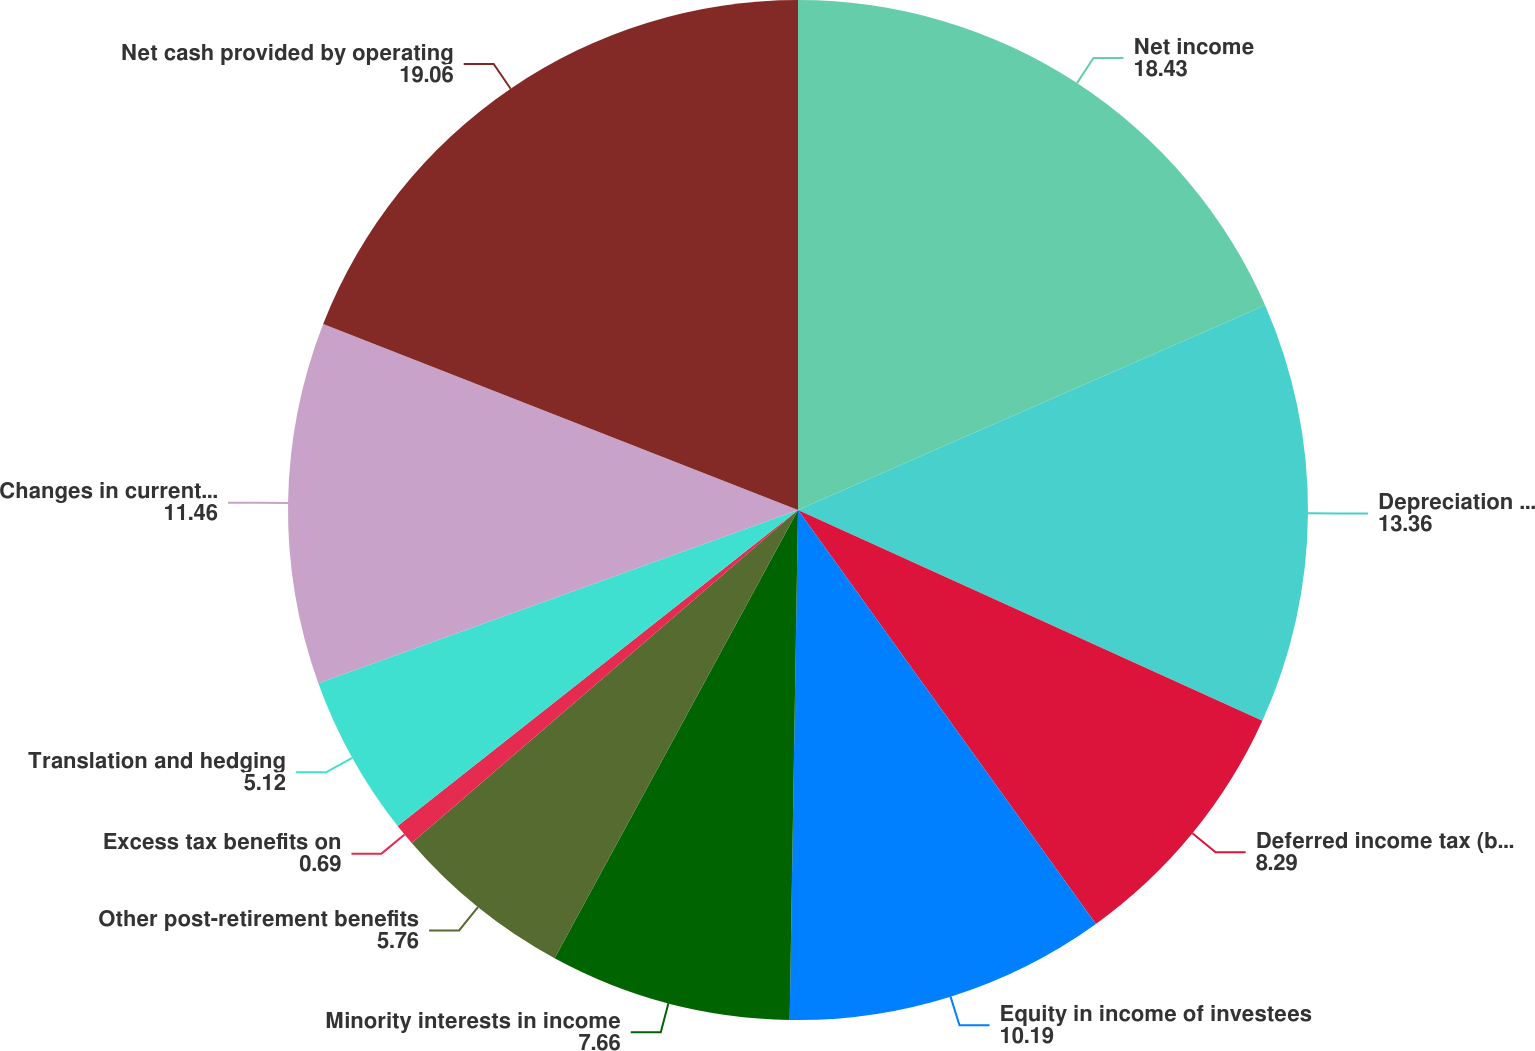Convert chart to OTSL. <chart><loc_0><loc_0><loc_500><loc_500><pie_chart><fcel>Net income<fcel>Depreciation and amortization<fcel>Deferred income tax (benefit)<fcel>Equity in income of investees<fcel>Minority interests in income<fcel>Other post-retirement benefits<fcel>Excess tax benefits on<fcel>Translation and hedging<fcel>Changes in current assets and<fcel>Net cash provided by operating<nl><fcel>18.43%<fcel>13.36%<fcel>8.29%<fcel>10.19%<fcel>7.66%<fcel>5.76%<fcel>0.69%<fcel>5.12%<fcel>11.46%<fcel>19.06%<nl></chart> 